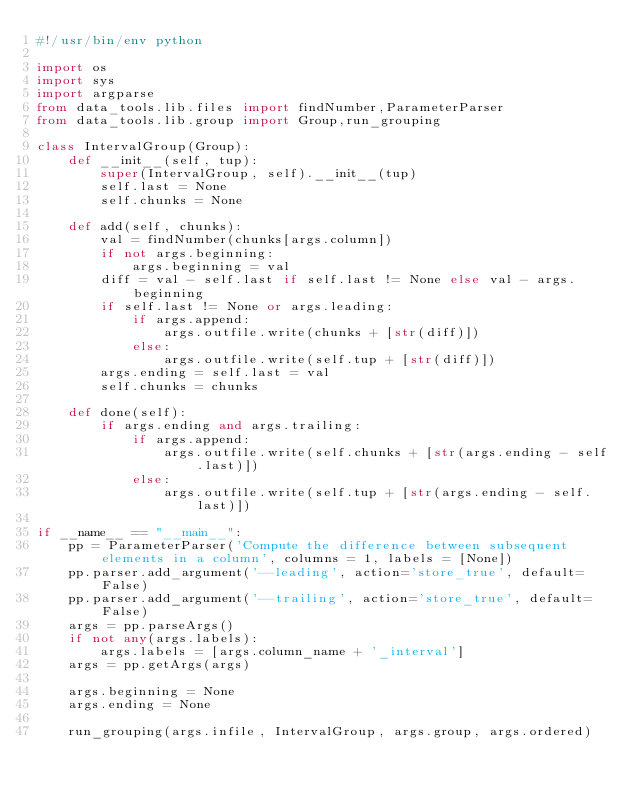Convert code to text. <code><loc_0><loc_0><loc_500><loc_500><_Python_>#!/usr/bin/env python

import os
import sys
import argparse
from data_tools.lib.files import findNumber,ParameterParser
from data_tools.lib.group import Group,run_grouping

class IntervalGroup(Group):
    def __init__(self, tup):
        super(IntervalGroup, self).__init__(tup)
        self.last = None
        self.chunks = None

    def add(self, chunks):
        val = findNumber(chunks[args.column])
        if not args.beginning:
            args.beginning = val
        diff = val - self.last if self.last != None else val - args.beginning
        if self.last != None or args.leading:
            if args.append:
                args.outfile.write(chunks + [str(diff)])
            else:
                args.outfile.write(self.tup + [str(diff)])
        args.ending = self.last = val
        self.chunks = chunks

    def done(self):
        if args.ending and args.trailing:
            if args.append:
                args.outfile.write(self.chunks + [str(args.ending - self.last)])
            else:
                args.outfile.write(self.tup + [str(args.ending - self.last)])

if __name__ == "__main__":
    pp = ParameterParser('Compute the difference between subsequent elements in a column', columns = 1, labels = [None])
    pp.parser.add_argument('--leading', action='store_true', default=False)
    pp.parser.add_argument('--trailing', action='store_true', default=False)
    args = pp.parseArgs()
    if not any(args.labels):
        args.labels = [args.column_name + '_interval']
    args = pp.getArgs(args)

    args.beginning = None
    args.ending = None

    run_grouping(args.infile, IntervalGroup, args.group, args.ordered)

</code> 